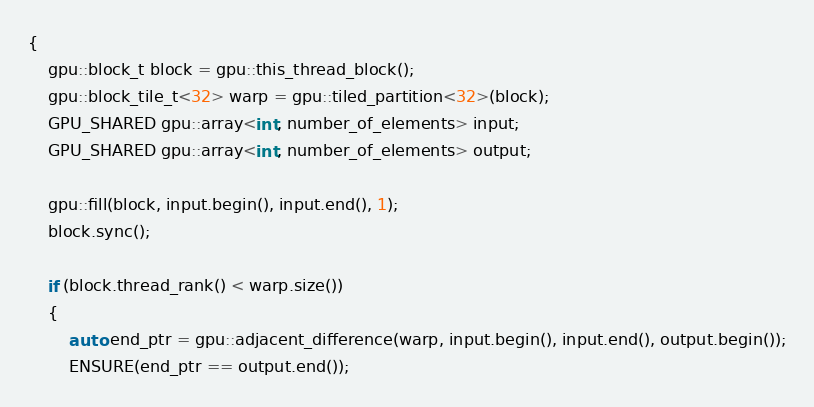<code> <loc_0><loc_0><loc_500><loc_500><_Cuda_>{
	gpu::block_t block = gpu::this_thread_block();
	gpu::block_tile_t<32> warp = gpu::tiled_partition<32>(block);
	GPU_SHARED gpu::array<int, number_of_elements> input;
	GPU_SHARED gpu::array<int, number_of_elements> output;

	gpu::fill(block, input.begin(), input.end(), 1);
	block.sync();

	if (block.thread_rank() < warp.size())
	{
		auto end_ptr = gpu::adjacent_difference(warp, input.begin(), input.end(), output.begin());
		ENSURE(end_ptr == output.end());</code> 